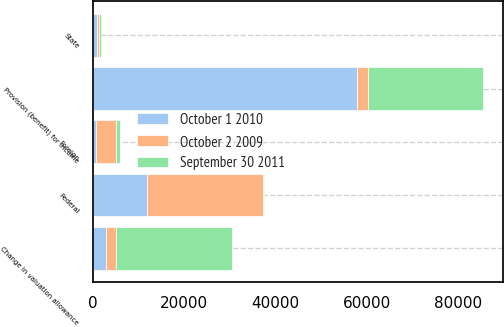<chart> <loc_0><loc_0><loc_500><loc_500><stacked_bar_chart><ecel><fcel>Federal<fcel>State<fcel>Foreign<fcel>Change in valuation allowance<fcel>Provision (benefit) for income<nl><fcel>October 2 2009<fcel>25421<fcel>422<fcel>4340<fcel>2152<fcel>2493<nl><fcel>October 1 2010<fcel>11855<fcel>946<fcel>684<fcel>2834<fcel>57780<nl><fcel>September 30 2011<fcel>251<fcel>413<fcel>966<fcel>25436<fcel>25227<nl></chart> 